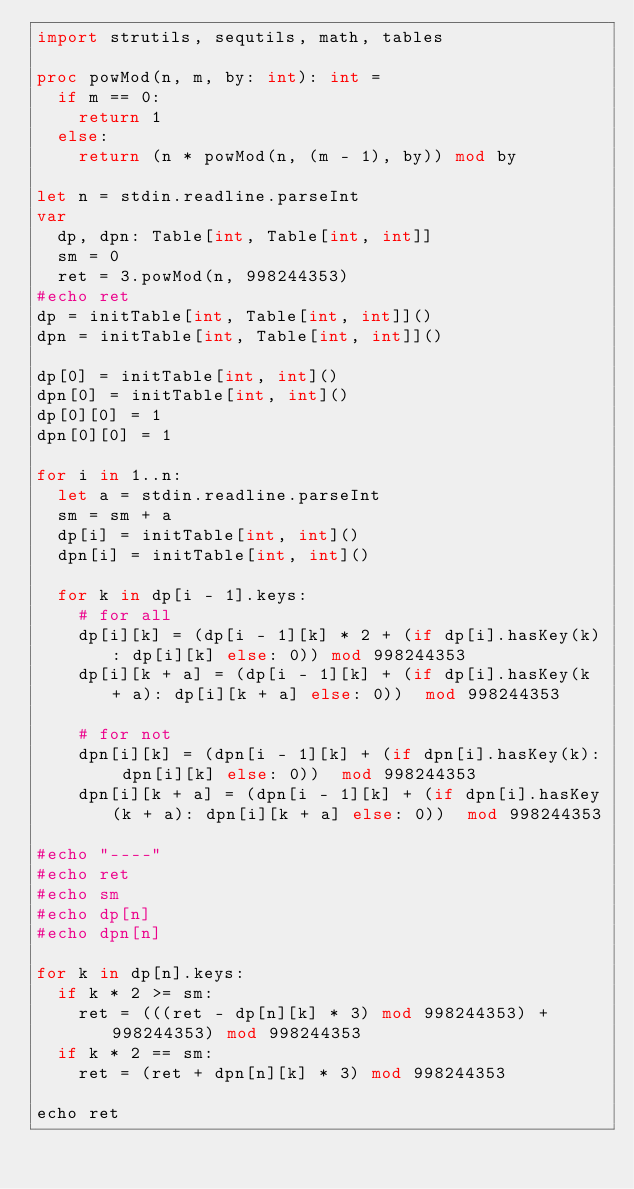<code> <loc_0><loc_0><loc_500><loc_500><_Nim_>import strutils, sequtils, math, tables

proc powMod(n, m, by: int): int =
  if m == 0:
    return 1
  else:
    return (n * powMod(n, (m - 1), by)) mod by

let n = stdin.readline.parseInt
var
  dp, dpn: Table[int, Table[int, int]]
  sm = 0
  ret = 3.powMod(n, 998244353)
#echo ret
dp = initTable[int, Table[int, int]]()
dpn = initTable[int, Table[int, int]]()

dp[0] = initTable[int, int]()
dpn[0] = initTable[int, int]()
dp[0][0] = 1
dpn[0][0] = 1

for i in 1..n:
  let a = stdin.readline.parseInt
  sm = sm + a
  dp[i] = initTable[int, int]()
  dpn[i] = initTable[int, int]()

  for k in dp[i - 1].keys:
    # for all
    dp[i][k] = (dp[i - 1][k] * 2 + (if dp[i].hasKey(k): dp[i][k] else: 0)) mod 998244353
    dp[i][k + a] = (dp[i - 1][k] + (if dp[i].hasKey(k + a): dp[i][k + a] else: 0))  mod 998244353

    # for not
    dpn[i][k] = (dpn[i - 1][k] + (if dpn[i].hasKey(k): dpn[i][k] else: 0))  mod 998244353
    dpn[i][k + a] = (dpn[i - 1][k] + (if dpn[i].hasKey(k + a): dpn[i][k + a] else: 0))  mod 998244353

#echo "----"
#echo ret
#echo sm
#echo dp[n]
#echo dpn[n]

for k in dp[n].keys:
  if k * 2 >= sm:
    ret = (((ret - dp[n][k] * 3) mod 998244353) + 998244353) mod 998244353
  if k * 2 == sm:
    ret = (ret + dpn[n][k] * 3) mod 998244353

echo ret
</code> 